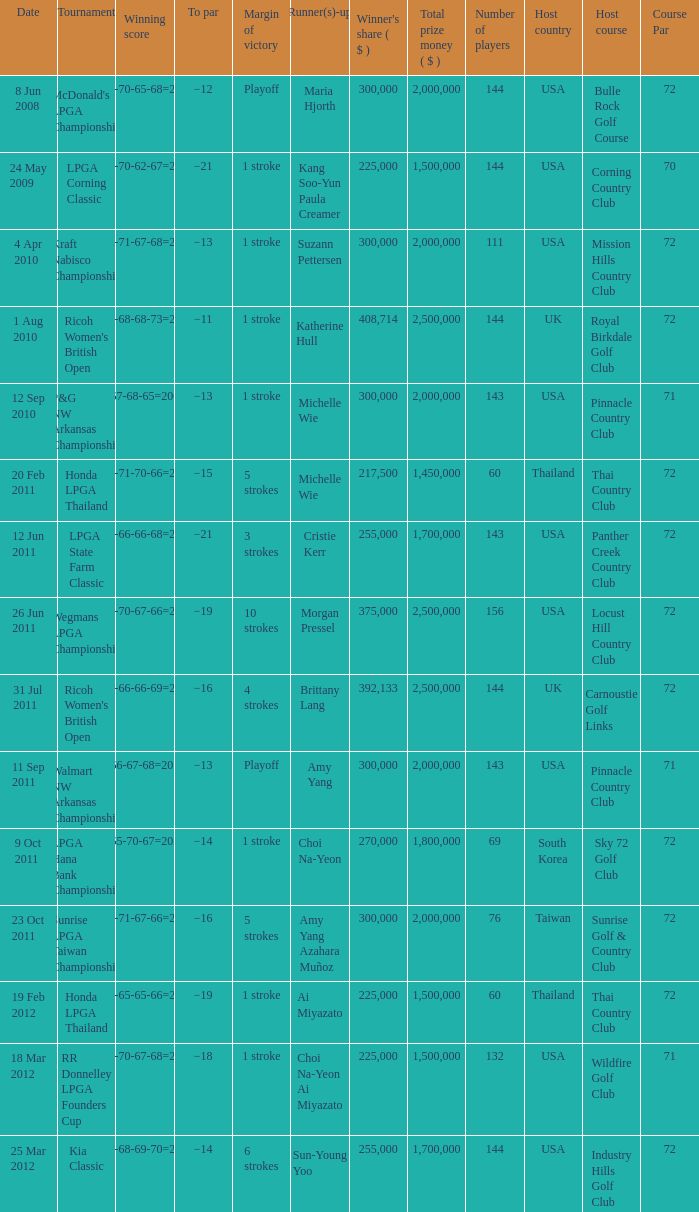Who was the runner-up in the RR Donnelley LPGA Founders Cup? Choi Na-Yeon Ai Miyazato. 